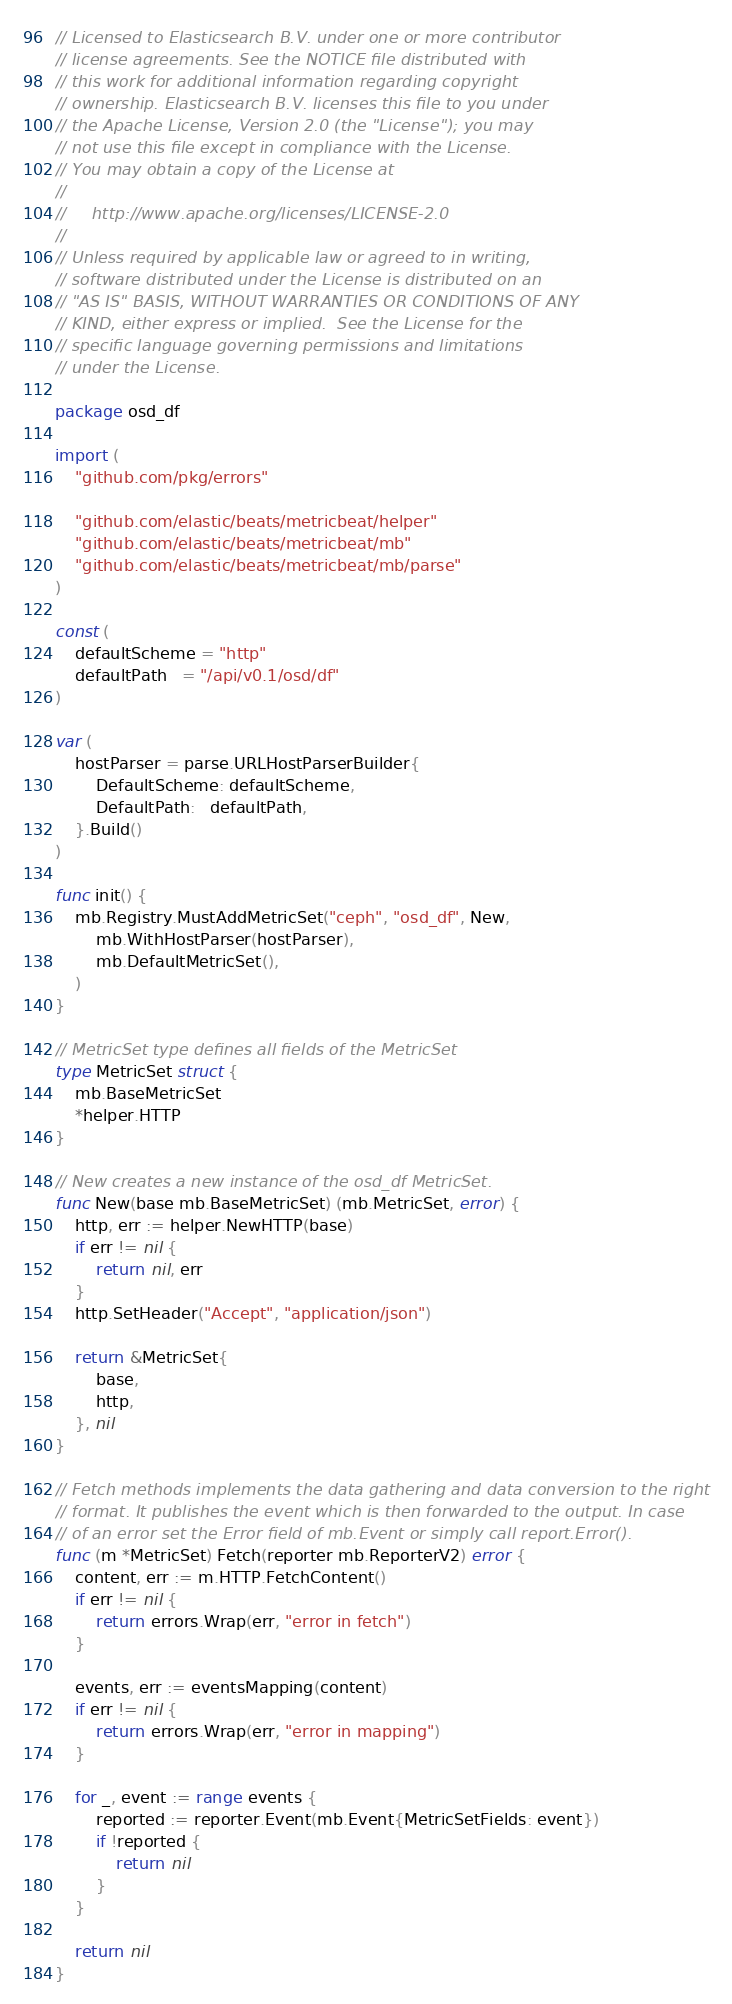Convert code to text. <code><loc_0><loc_0><loc_500><loc_500><_Go_>// Licensed to Elasticsearch B.V. under one or more contributor
// license agreements. See the NOTICE file distributed with
// this work for additional information regarding copyright
// ownership. Elasticsearch B.V. licenses this file to you under
// the Apache License, Version 2.0 (the "License"); you may
// not use this file except in compliance with the License.
// You may obtain a copy of the License at
//
//     http://www.apache.org/licenses/LICENSE-2.0
//
// Unless required by applicable law or agreed to in writing,
// software distributed under the License is distributed on an
// "AS IS" BASIS, WITHOUT WARRANTIES OR CONDITIONS OF ANY
// KIND, either express or implied.  See the License for the
// specific language governing permissions and limitations
// under the License.

package osd_df

import (
	"github.com/pkg/errors"

	"github.com/elastic/beats/metricbeat/helper"
	"github.com/elastic/beats/metricbeat/mb"
	"github.com/elastic/beats/metricbeat/mb/parse"
)

const (
	defaultScheme = "http"
	defaultPath   = "/api/v0.1/osd/df"
)

var (
	hostParser = parse.URLHostParserBuilder{
		DefaultScheme: defaultScheme,
		DefaultPath:   defaultPath,
	}.Build()
)

func init() {
	mb.Registry.MustAddMetricSet("ceph", "osd_df", New,
		mb.WithHostParser(hostParser),
		mb.DefaultMetricSet(),
	)
}

// MetricSet type defines all fields of the MetricSet
type MetricSet struct {
	mb.BaseMetricSet
	*helper.HTTP
}

// New creates a new instance of the osd_df MetricSet.
func New(base mb.BaseMetricSet) (mb.MetricSet, error) {
	http, err := helper.NewHTTP(base)
	if err != nil {
		return nil, err
	}
	http.SetHeader("Accept", "application/json")

	return &MetricSet{
		base,
		http,
	}, nil
}

// Fetch methods implements the data gathering and data conversion to the right
// format. It publishes the event which is then forwarded to the output. In case
// of an error set the Error field of mb.Event or simply call report.Error().
func (m *MetricSet) Fetch(reporter mb.ReporterV2) error {
	content, err := m.HTTP.FetchContent()
	if err != nil {
		return errors.Wrap(err, "error in fetch")
	}

	events, err := eventsMapping(content)
	if err != nil {
		return errors.Wrap(err, "error in mapping")
	}

	for _, event := range events {
		reported := reporter.Event(mb.Event{MetricSetFields: event})
		if !reported {
			return nil
		}
	}

	return nil
}
</code> 